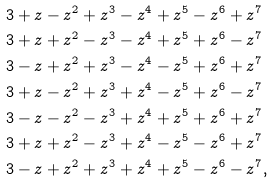Convert formula to latex. <formula><loc_0><loc_0><loc_500><loc_500>& 3 + z - z ^ { 2 } + z ^ { 3 } - z ^ { 4 } + z ^ { 5 } - z ^ { 6 } + z ^ { 7 } \\ & 3 + z + z ^ { 2 } - z ^ { 3 } - z ^ { 4 } + z ^ { 5 } + z ^ { 6 } - z ^ { 7 } \\ & 3 - z + z ^ { 2 } + z ^ { 3 } - z ^ { 4 } - z ^ { 5 } + z ^ { 6 } + z ^ { 7 } \\ & 3 + z - z ^ { 2 } + z ^ { 3 } + z ^ { 4 } - z ^ { 5 } + z ^ { 6 } - z ^ { 7 } \\ & 3 - z - z ^ { 2 } - z ^ { 3 } + z ^ { 4 } + z ^ { 5 } + z ^ { 6 } + z ^ { 7 } \\ & 3 + z + z ^ { 2 } - z ^ { 3 } + z ^ { 4 } - z ^ { 5 } - z ^ { 6 } + z ^ { 7 } \\ & 3 - z + z ^ { 2 } + z ^ { 3 } + z ^ { 4 } + z ^ { 5 } - z ^ { 6 } - z ^ { 7 } ,</formula> 